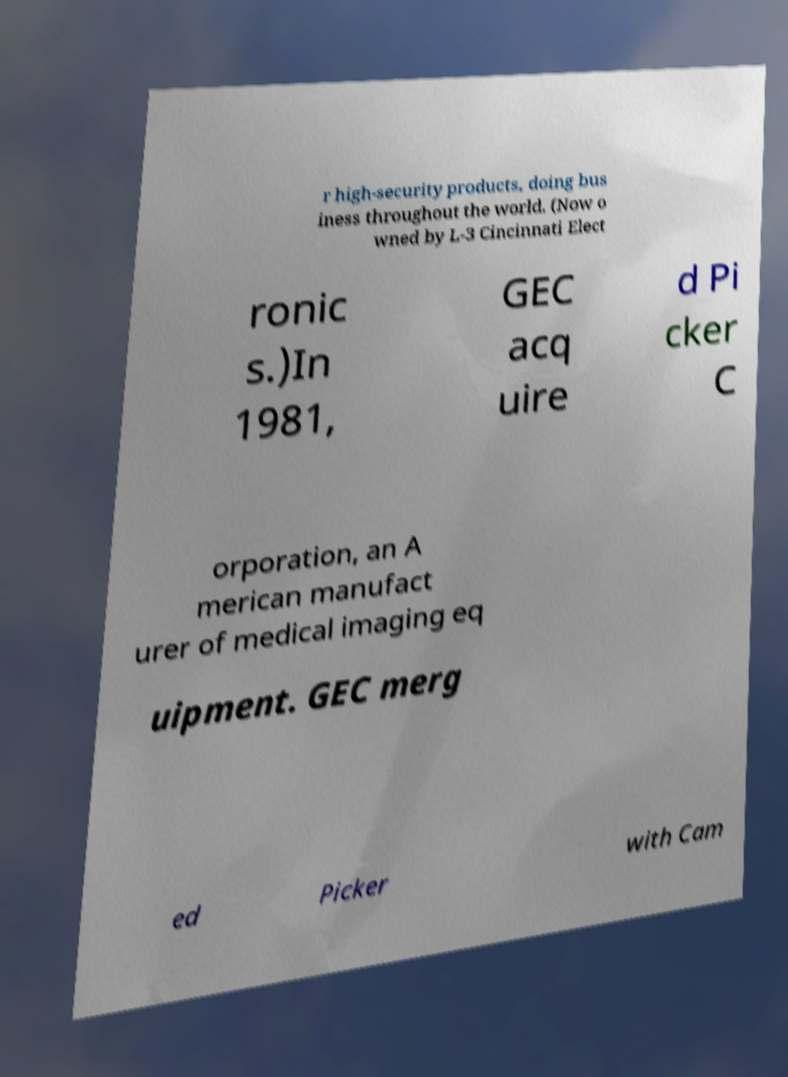Please identify and transcribe the text found in this image. r high-security products, doing bus iness throughout the world. (Now o wned by L-3 Cincinnati Elect ronic s.)In 1981, GEC acq uire d Pi cker C orporation, an A merican manufact urer of medical imaging eq uipment. GEC merg ed Picker with Cam 